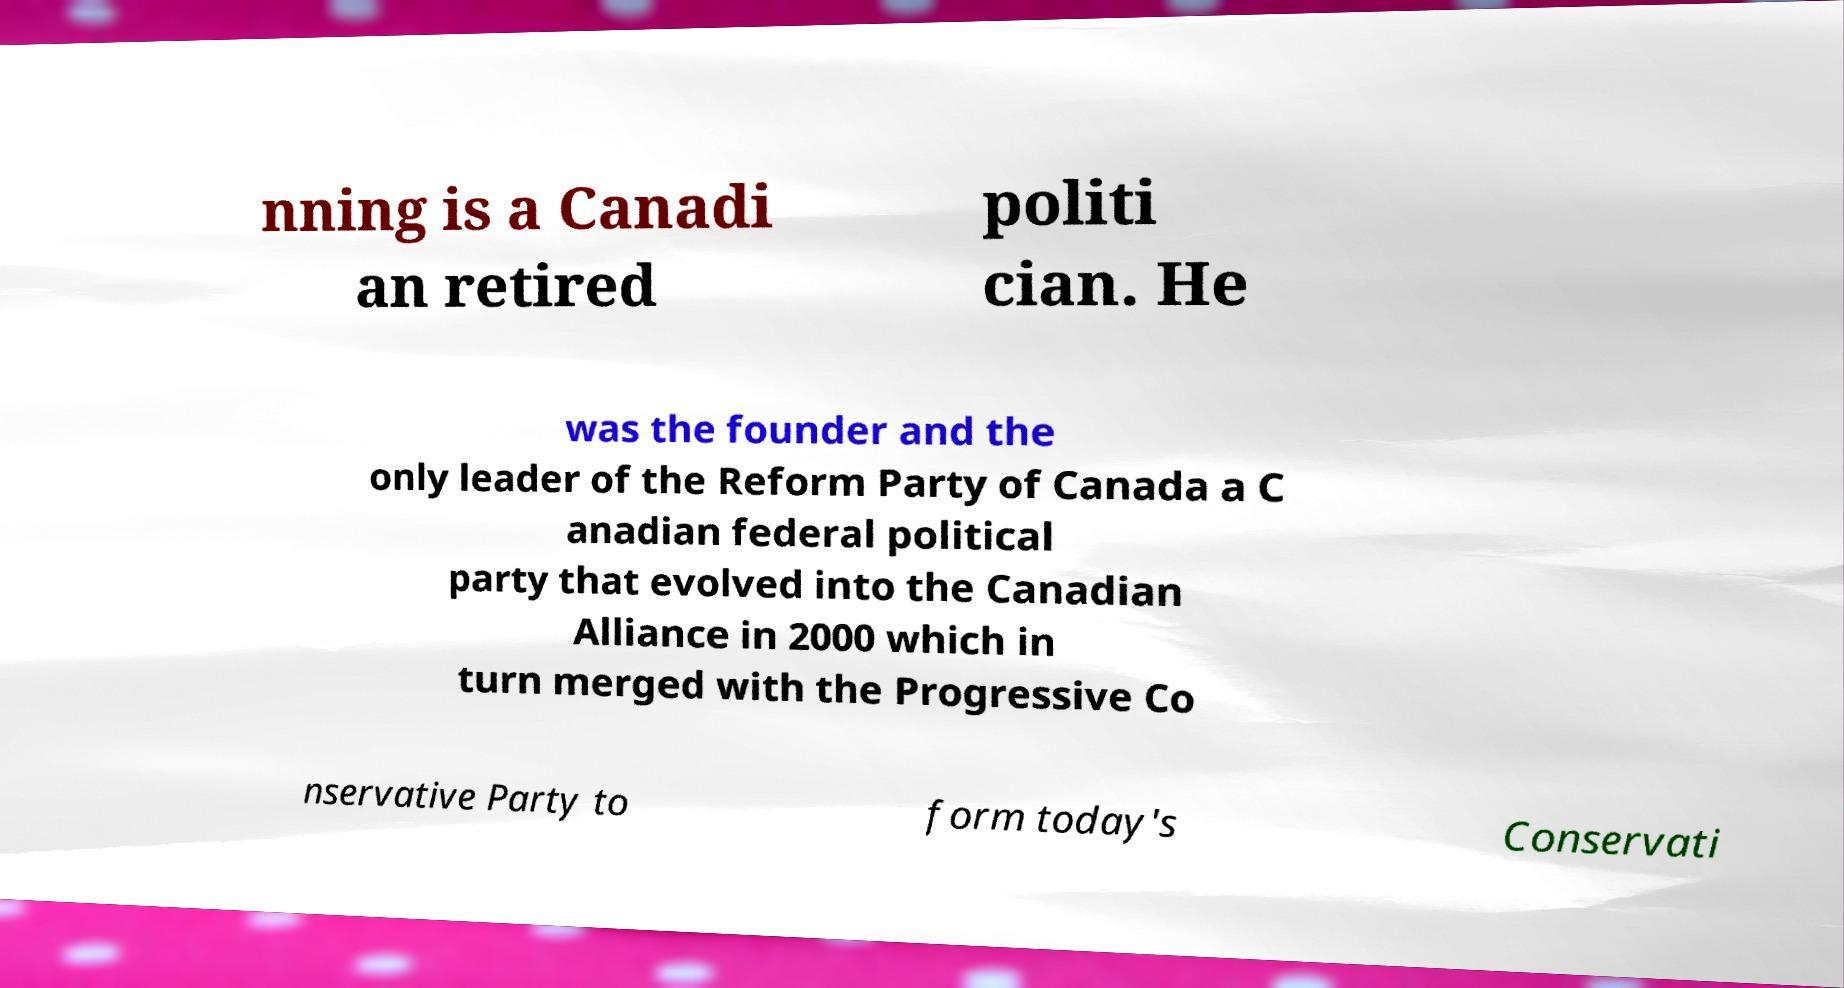What messages or text are displayed in this image? I need them in a readable, typed format. nning is a Canadi an retired politi cian. He was the founder and the only leader of the Reform Party of Canada a C anadian federal political party that evolved into the Canadian Alliance in 2000 which in turn merged with the Progressive Co nservative Party to form today's Conservati 